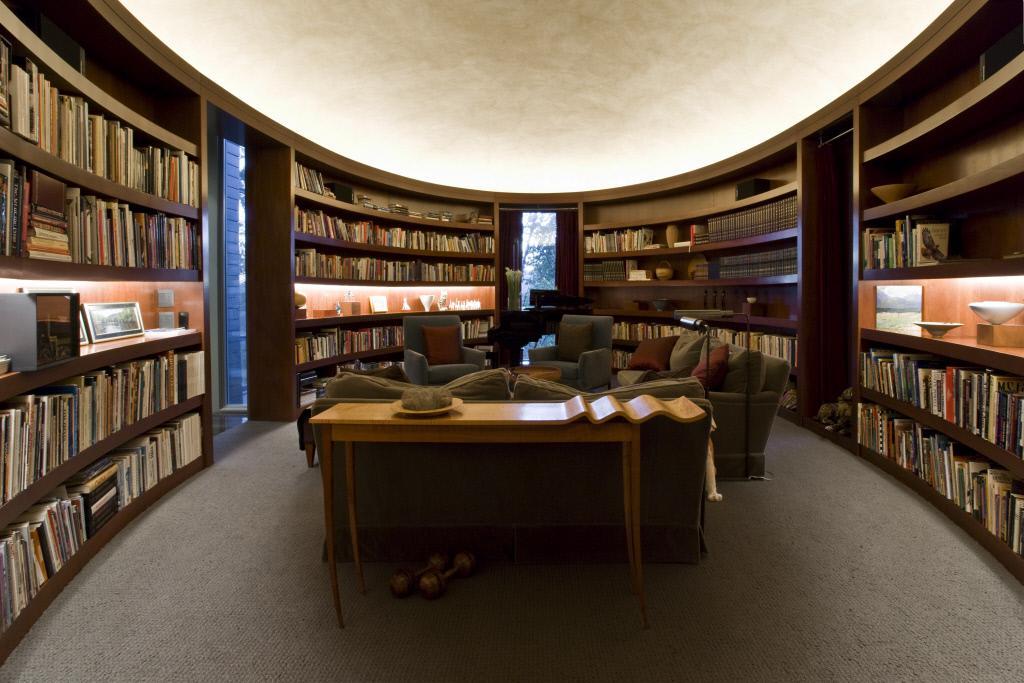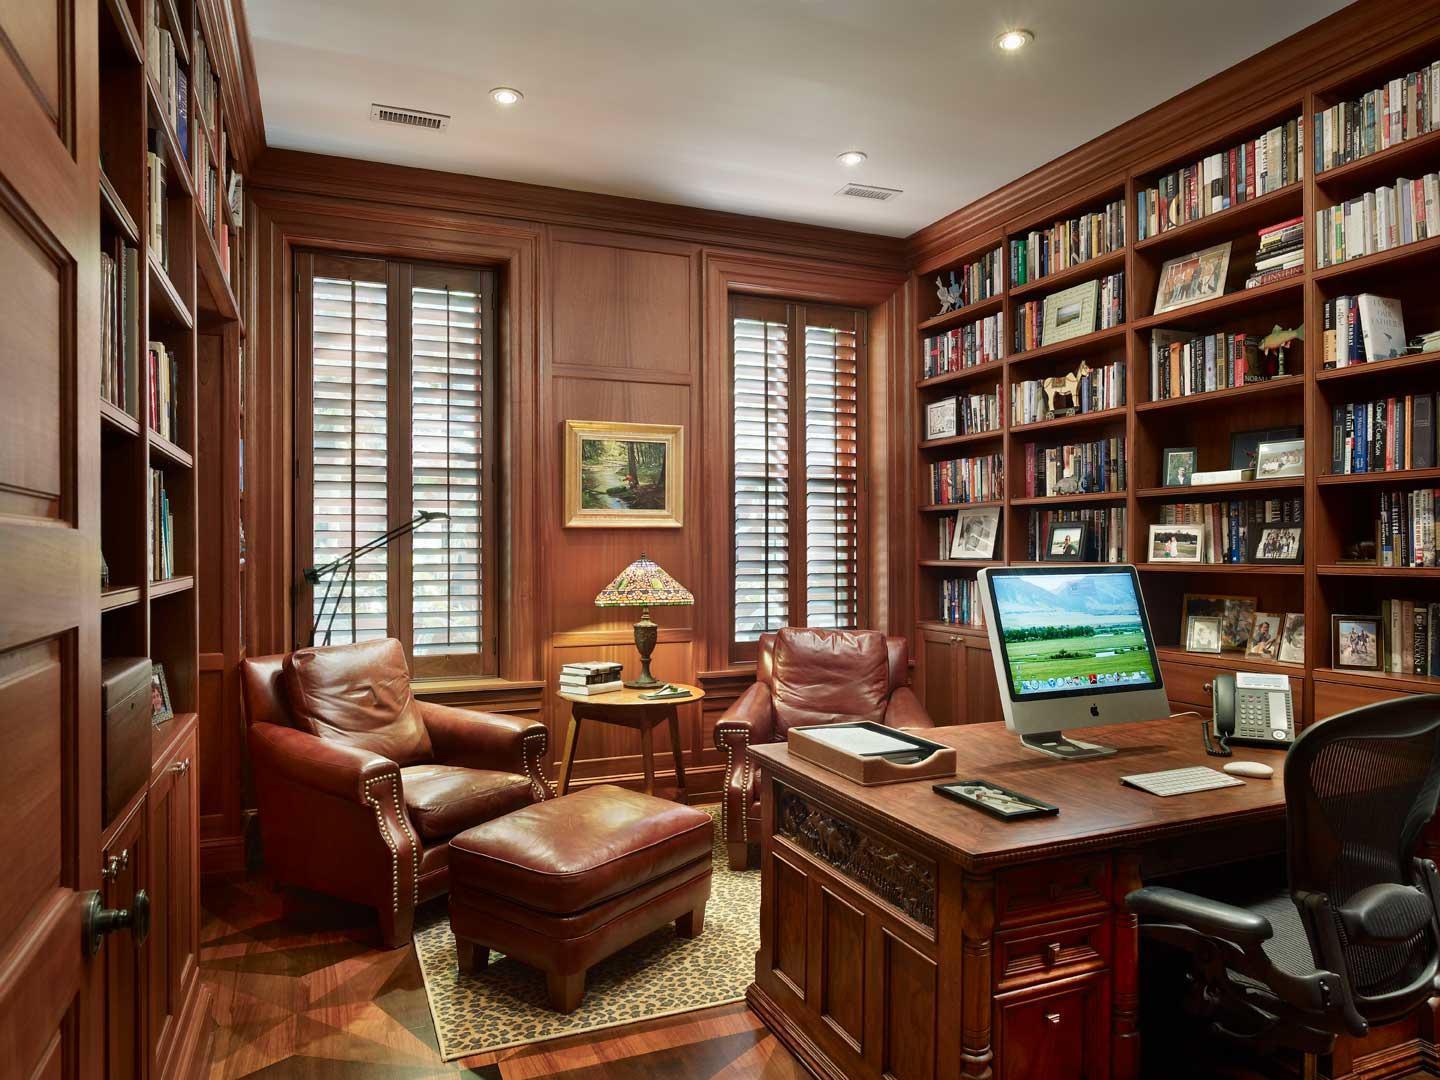The first image is the image on the left, the second image is the image on the right. Analyze the images presented: Is the assertion "A room with a bookcase includes a flight of stairs." valid? Answer yes or no. No. 